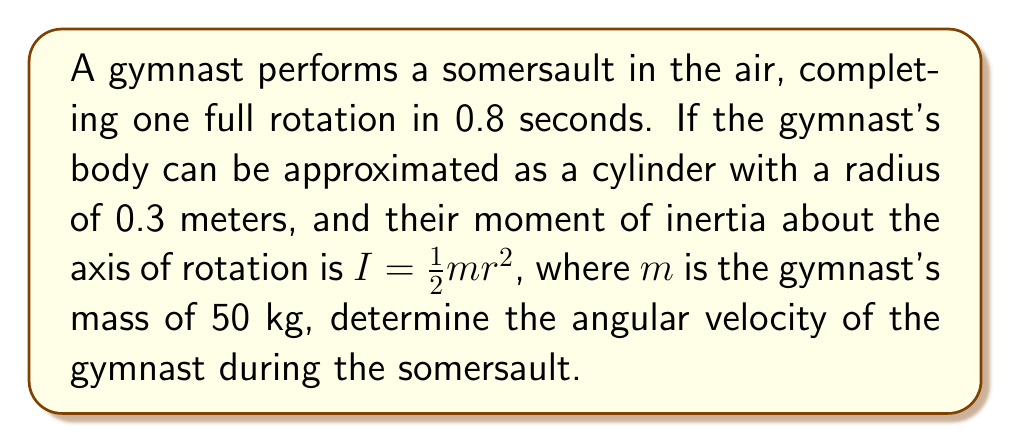Can you solve this math problem? To solve this problem, we'll follow these steps:

1) First, let's recall that angular velocity $\omega$ is defined as the rate of change of angular displacement $\theta$ with respect to time $t$:

   $\omega = \frac{d\theta}{dt}$

2) In this case, we know that one full rotation occurs in 0.8 seconds. One full rotation corresponds to $2\pi$ radians. So we can calculate the average angular velocity:

   $\omega = \frac{\Delta \theta}{\Delta t} = \frac{2\pi \text{ rad}}{0.8 \text{ s}} = \frac{5\pi}{2} \text{ rad/s}$

3) Now, let's verify this using the moment of inertia and angular momentum conservation. The moment of inertia $I$ for a cylinder rotating about its central axis is given by:

   $I = \frac{1}{2}mr^2$

4) Substituting the given values:

   $I = \frac{1}{2} \cdot 50 \text{ kg} \cdot (0.3 \text{ m})^2 = 2.25 \text{ kg}\cdot\text{m}^2$

5) The angular momentum $L$ is conserved during the somersault (assuming air resistance is negligible). It's given by:

   $L = I\omega$

6) We can calculate $L$ using our previously found $\omega$:

   $L = 2.25 \text{ kg}\cdot\text{m}^2 \cdot \frac{5\pi}{2} \text{ rad/s} = \frac{25\pi}{4} \text{ kg}\cdot\text{m}^2/\text{s}$

7) This confirms our calculation of angular velocity, as:

   $\omega = \frac{L}{I} = \frac{25\pi/4}{2.25} = \frac{5\pi}{2} \text{ rad/s}$

Therefore, the angular velocity of the gymnast during the somersault is $\frac{5\pi}{2}$ rad/s or approximately 7.85 rad/s.
Answer: $\frac{5\pi}{2}$ rad/s 